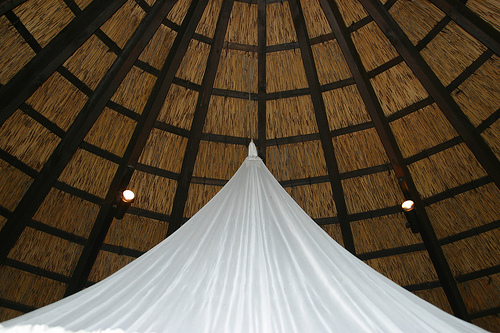<image>
Can you confirm if the tent is on the grass? No. The tent is not positioned on the grass. They may be near each other, but the tent is not supported by or resting on top of the grass. 